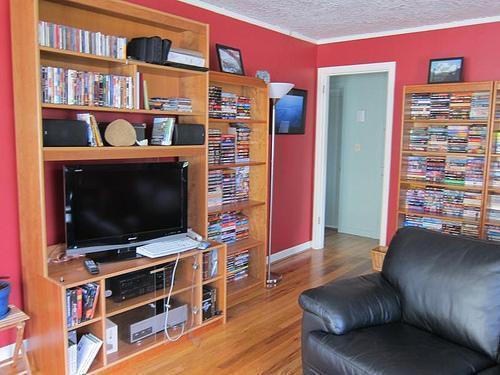How many televisions are in the photo?
Give a very brief answer. 1. How many independent book shelves are in the room?
Give a very brief answer. 3. How many pictures are on top of bookcases in this room?
Give a very brief answer. 2. How many pictures are hanging on the wall in this photo?
Give a very brief answer. 1. 